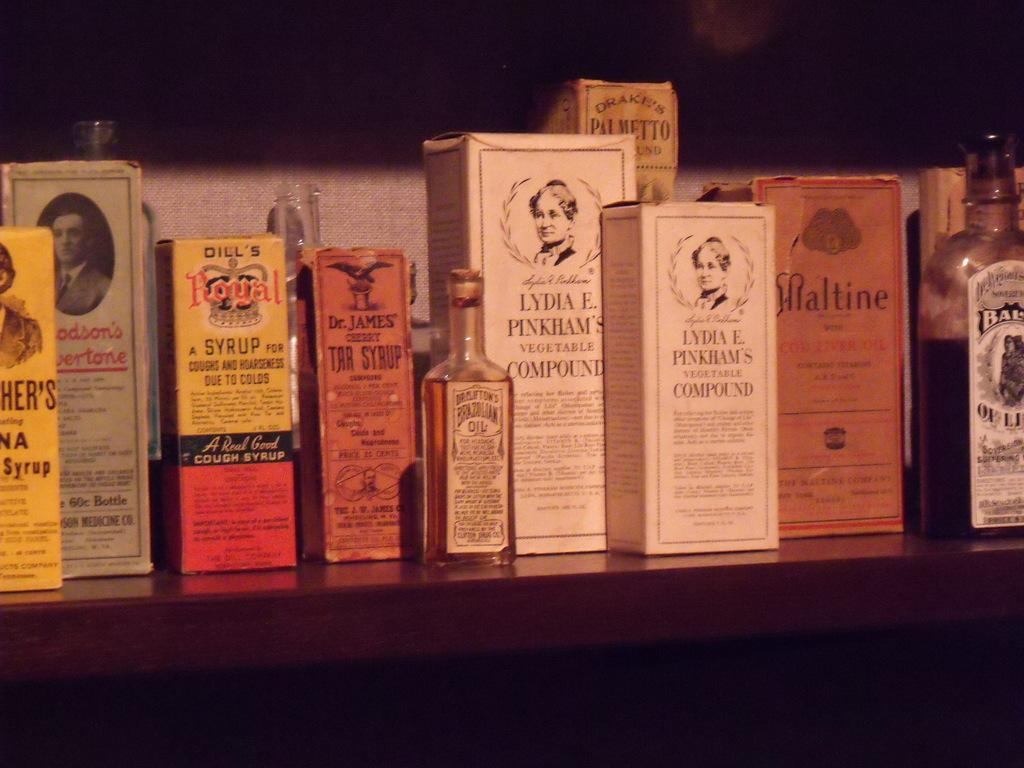<image>
Offer a succinct explanation of the picture presented. Many old medicine boxes are displayed, including Royal Syrup and Lydia E. Pinkham's Vegetable Compoud. 